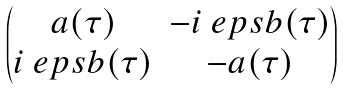Convert formula to latex. <formula><loc_0><loc_0><loc_500><loc_500>\begin{pmatrix} a ( \tau ) & - i \ e p s b ( \tau ) \\ i \ e p s b ( \tau ) & - a ( \tau ) \end{pmatrix}</formula> 